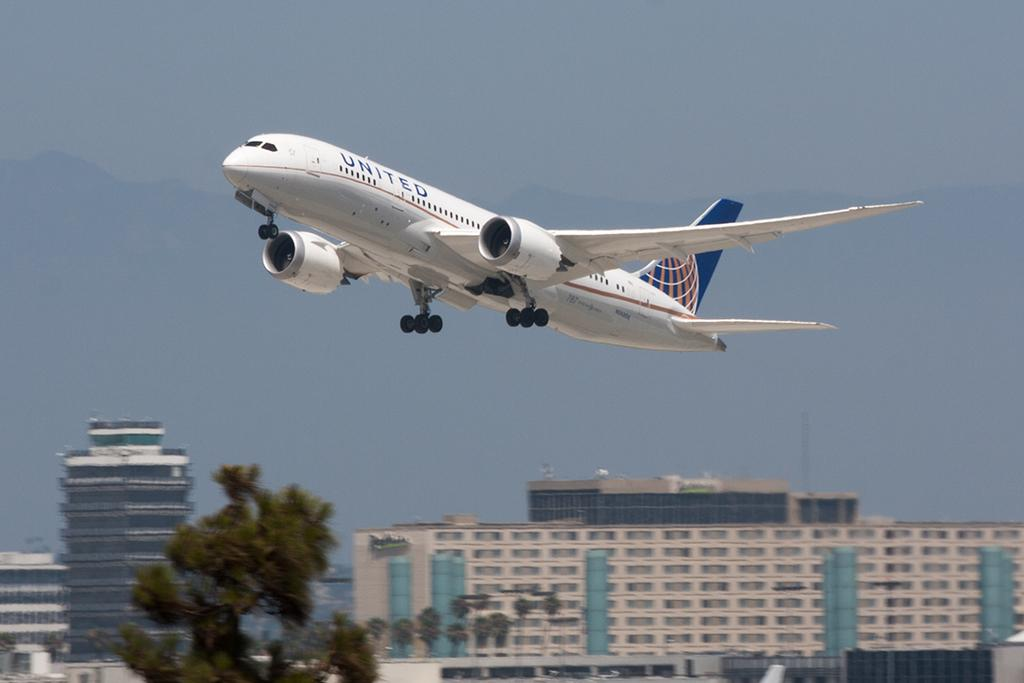<image>
Create a compact narrative representing the image presented. A United airplane is taking off into the sky. 